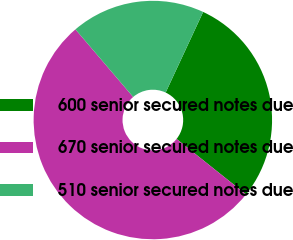Convert chart. <chart><loc_0><loc_0><loc_500><loc_500><pie_chart><fcel>600 senior secured notes due<fcel>670 senior secured notes due<fcel>510 senior secured notes due<nl><fcel>28.79%<fcel>53.03%<fcel>18.18%<nl></chart> 